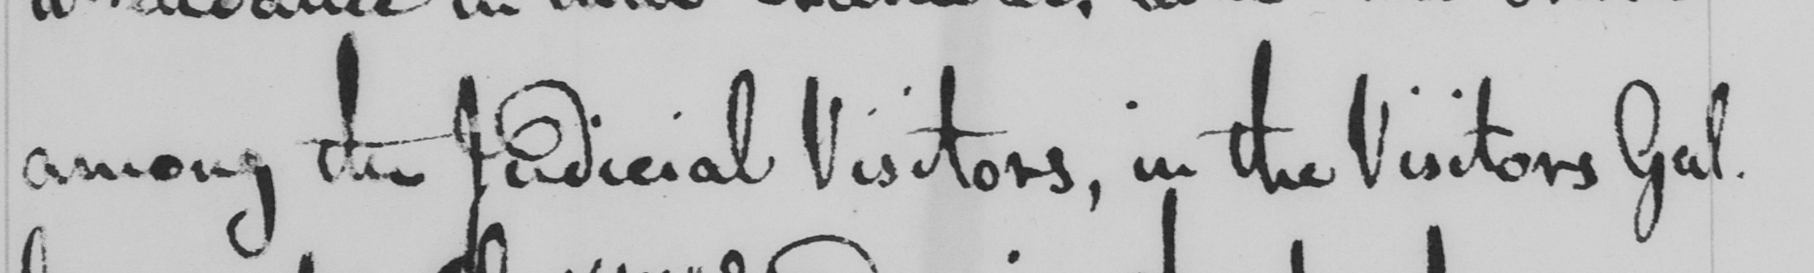Can you tell me what this handwritten text says? among the Judicial Visitors , in the Visitors Gal- 